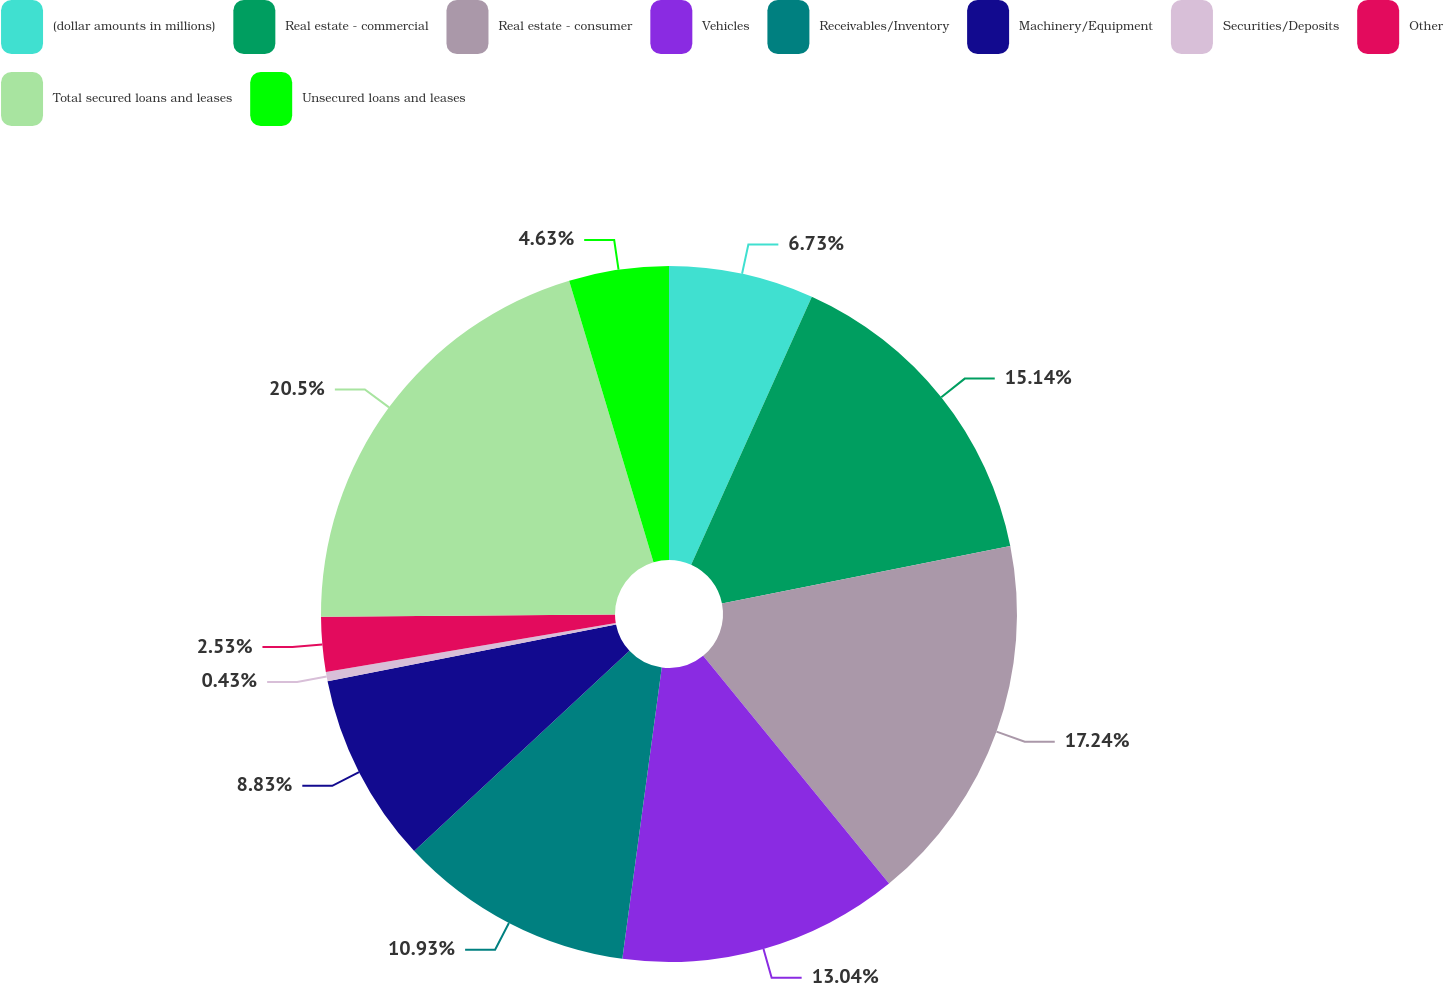Convert chart. <chart><loc_0><loc_0><loc_500><loc_500><pie_chart><fcel>(dollar amounts in millions)<fcel>Real estate - commercial<fcel>Real estate - consumer<fcel>Vehicles<fcel>Receivables/Inventory<fcel>Machinery/Equipment<fcel>Securities/Deposits<fcel>Other<fcel>Total secured loans and leases<fcel>Unsecured loans and leases<nl><fcel>6.73%<fcel>15.13%<fcel>17.23%<fcel>13.03%<fcel>10.93%<fcel>8.83%<fcel>0.43%<fcel>2.53%<fcel>20.49%<fcel>4.63%<nl></chart> 